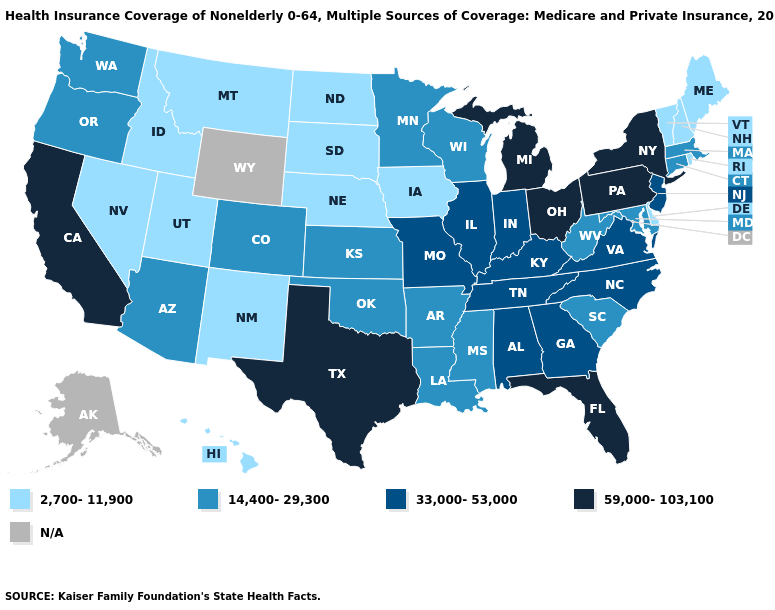What is the value of North Carolina?
Give a very brief answer. 33,000-53,000. What is the value of Florida?
Short answer required. 59,000-103,100. Among the states that border Oklahoma , which have the lowest value?
Short answer required. New Mexico. Does Nebraska have the lowest value in the MidWest?
Quick response, please. Yes. What is the lowest value in states that border Montana?
Short answer required. 2,700-11,900. Among the states that border Idaho , does Oregon have the lowest value?
Write a very short answer. No. What is the value of California?
Short answer required. 59,000-103,100. Name the states that have a value in the range 2,700-11,900?
Write a very short answer. Delaware, Hawaii, Idaho, Iowa, Maine, Montana, Nebraska, Nevada, New Hampshire, New Mexico, North Dakota, Rhode Island, South Dakota, Utah, Vermont. Is the legend a continuous bar?
Short answer required. No. What is the value of Ohio?
Keep it brief. 59,000-103,100. Which states have the highest value in the USA?
Quick response, please. California, Florida, Michigan, New York, Ohio, Pennsylvania, Texas. Which states have the lowest value in the West?
Short answer required. Hawaii, Idaho, Montana, Nevada, New Mexico, Utah. What is the highest value in the USA?
Quick response, please. 59,000-103,100. 